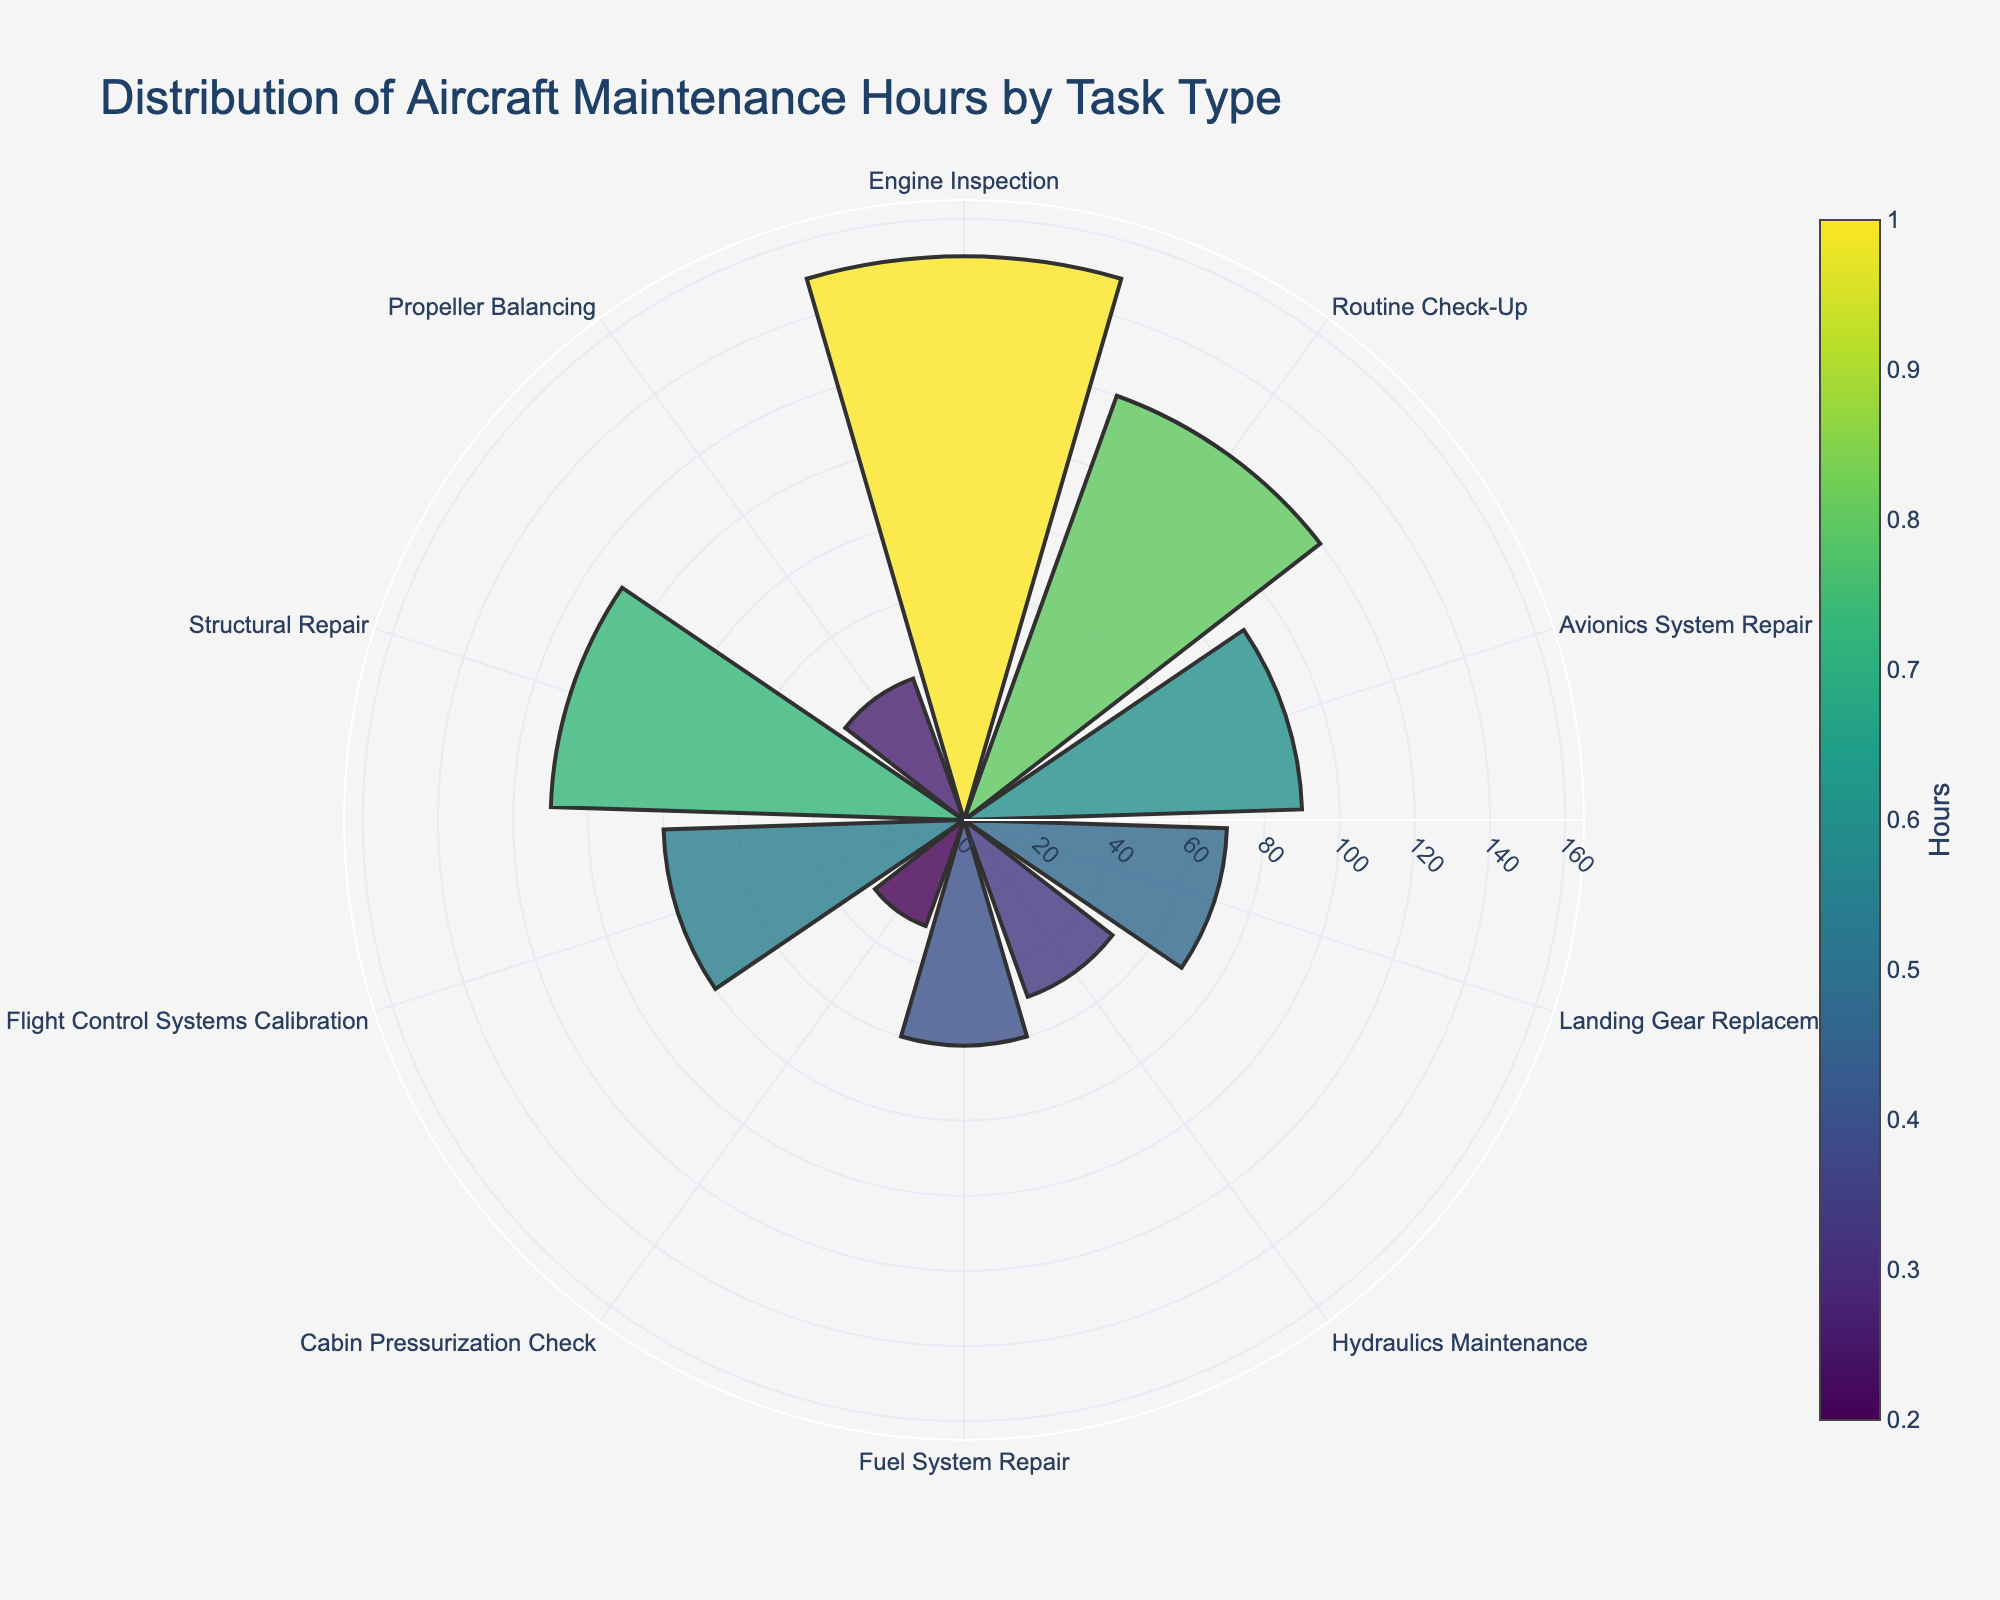How many tasks are listed in the chart? Count the number of segments in the polar area chart.
Answer: 10 Which task requires the most maintenance hours? Identify the segment with the largest radius.
Answer: Engine Inspection How many more hours are spent on Structural Repair compared to Propeller Balancing? Find the radii corresponding to Structural Repair and Propeller Balancing, then subtract the smaller from the larger. 110 (Structural Repair) - 40 (Propeller Balancing) = 70
Answer: 70 What is the average number of hours spent on all tasks? Sum all the hours and then divide by the number of tasks. (150 + 120 + 90 + 70 + 50 + 60 + 30 + 80 + 110 + 40) / 10 = 80
Answer: 80 Which tasks require less than 50 hours of maintenance? Identify the segments with radii less than 50.
Answer: Cabin Pressurization Check, Propeller Balancing How does the time spent on Avionics System Repair compare to Hydraulics Maintenance? Compare the radii of the segments for Avionics System Repair and Hydraulics Maintenance. Avionics System Repair (90) is greater than Hydraulics Maintenance (50).
Answer: Avionics System Repair requires more hours What is the difference in hours between the task with the most hours and the task with the least hours? Subtract the radius of the smallest segment from the radius of the largest segment. 150 (most) - 30 (least) = 120
Answer: 120 What proportion of the total hours is spent on Engine Inspection? Sum all the hours to get the total, then divide the hours for Engine Inspection by this total, and multiply by 100 to convert to a percentage. (150 / 800) * 100 = 18.75%
Answer: 18.75% Which task type is closest to requiring an average number of hours for maintenance? Calculate the average number of hours (80), then find the task type whose hours are closest to this value. Flight Control Systems Calibration is closest with 80 hours.
Answer: Flight Control Systems Calibration What is the combined total of hours spent on Routine Check-Up and Structural Repair? Add the maintenance hours for Routine Check-Up and Structural Repair. 120 + 110 = 230
Answer: 230 